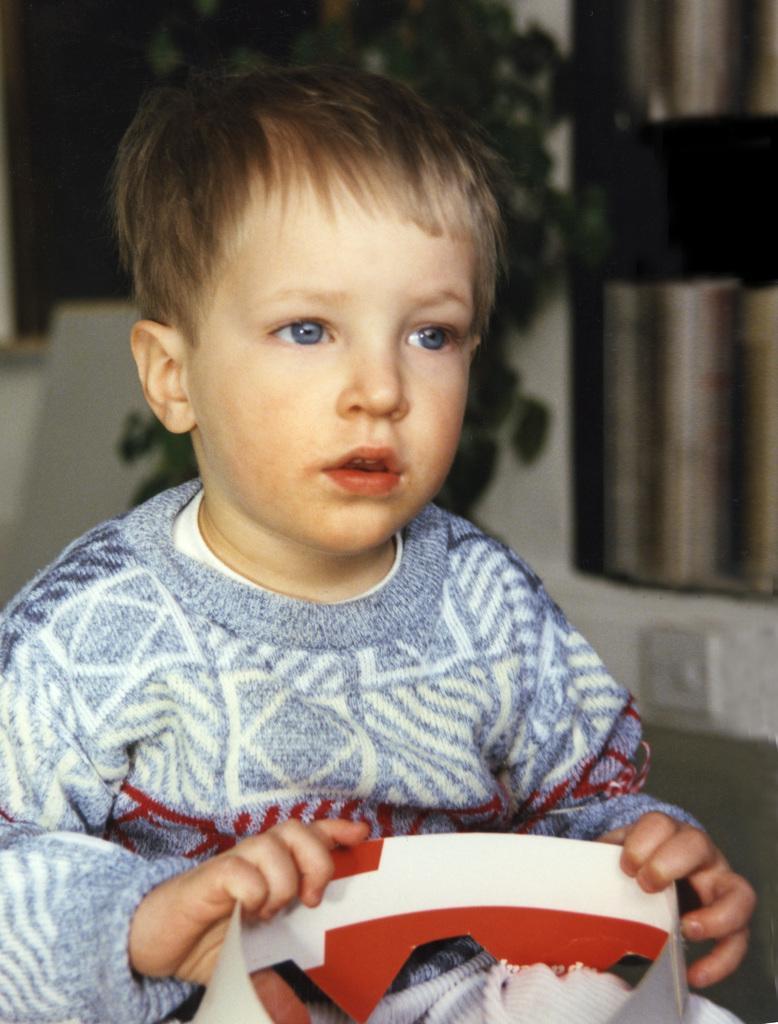Can you describe this image briefly? In this image we can see a boy holding the paper bag in his hands. 